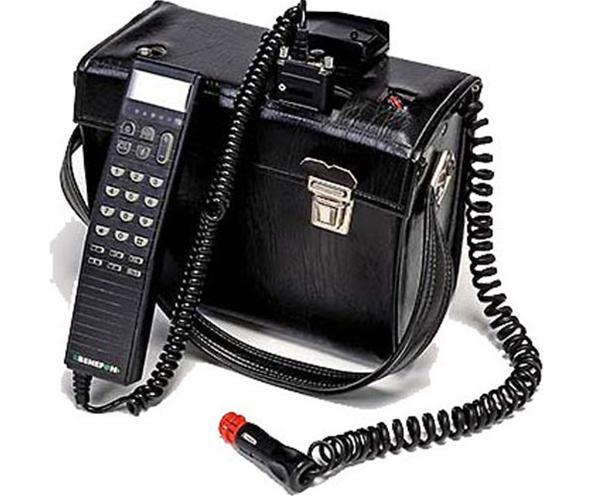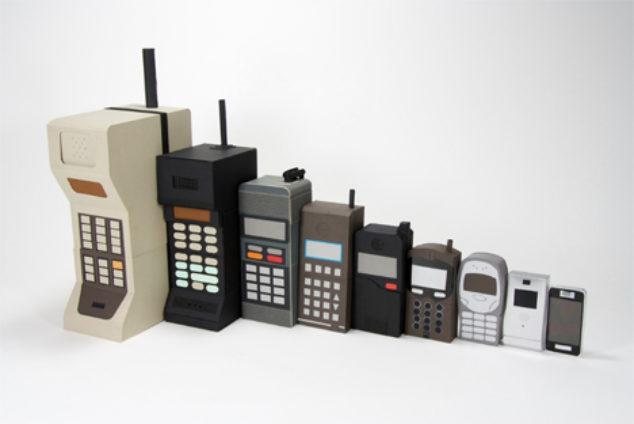The first image is the image on the left, the second image is the image on the right. Considering the images on both sides, is "Each image contains only a single phone with an antennae on top and a flat, rectangular base." valid? Answer yes or no. No. The first image is the image on the left, the second image is the image on the right. For the images displayed, is the sentence "The left and right image contains the same number of phones." factually correct? Answer yes or no. No. 